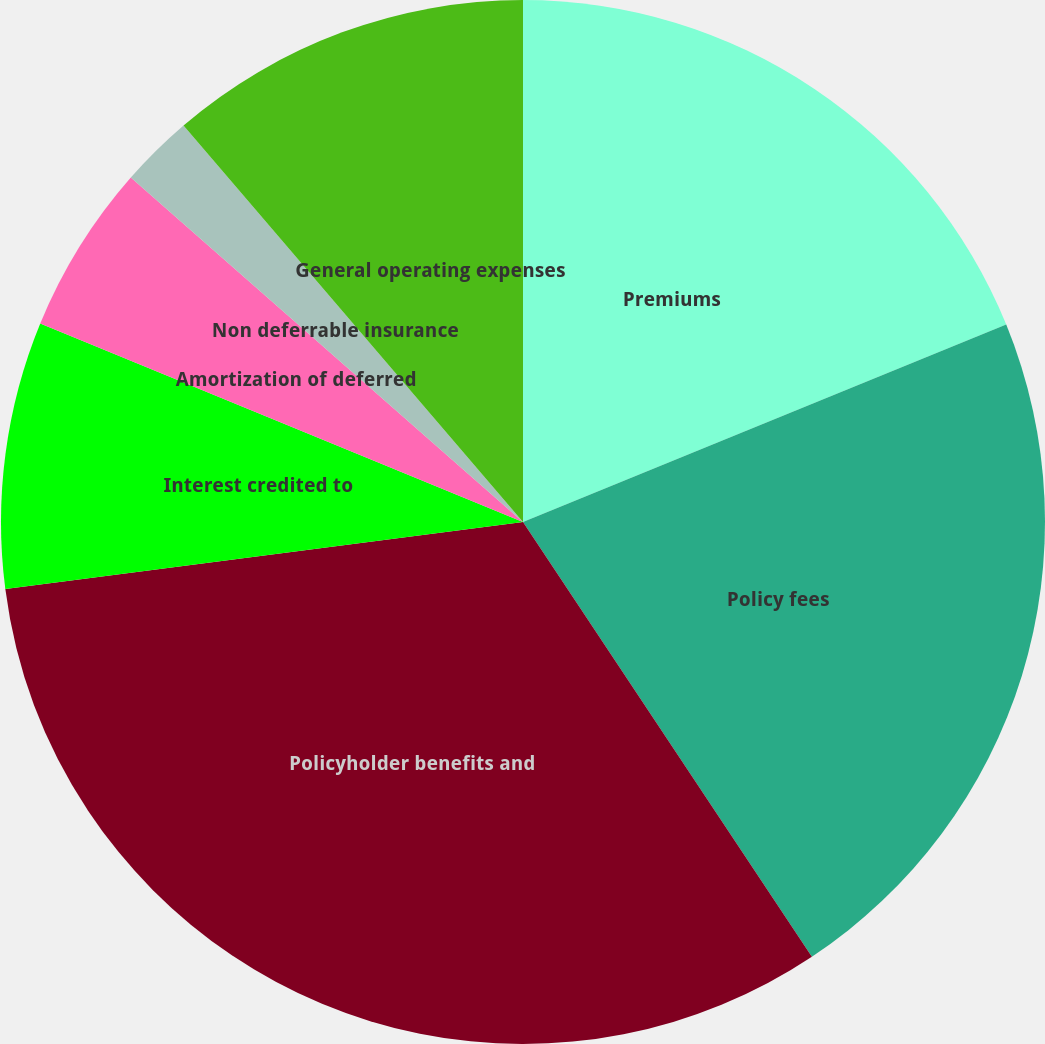<chart> <loc_0><loc_0><loc_500><loc_500><pie_chart><fcel>Premiums<fcel>Policy fees<fcel>Policyholder benefits and<fcel>Interest credited to<fcel>Amortization of deferred<fcel>Non deferrable insurance<fcel>General operating expenses<nl><fcel>18.83%<fcel>21.84%<fcel>32.29%<fcel>8.26%<fcel>5.26%<fcel>2.26%<fcel>11.27%<nl></chart> 